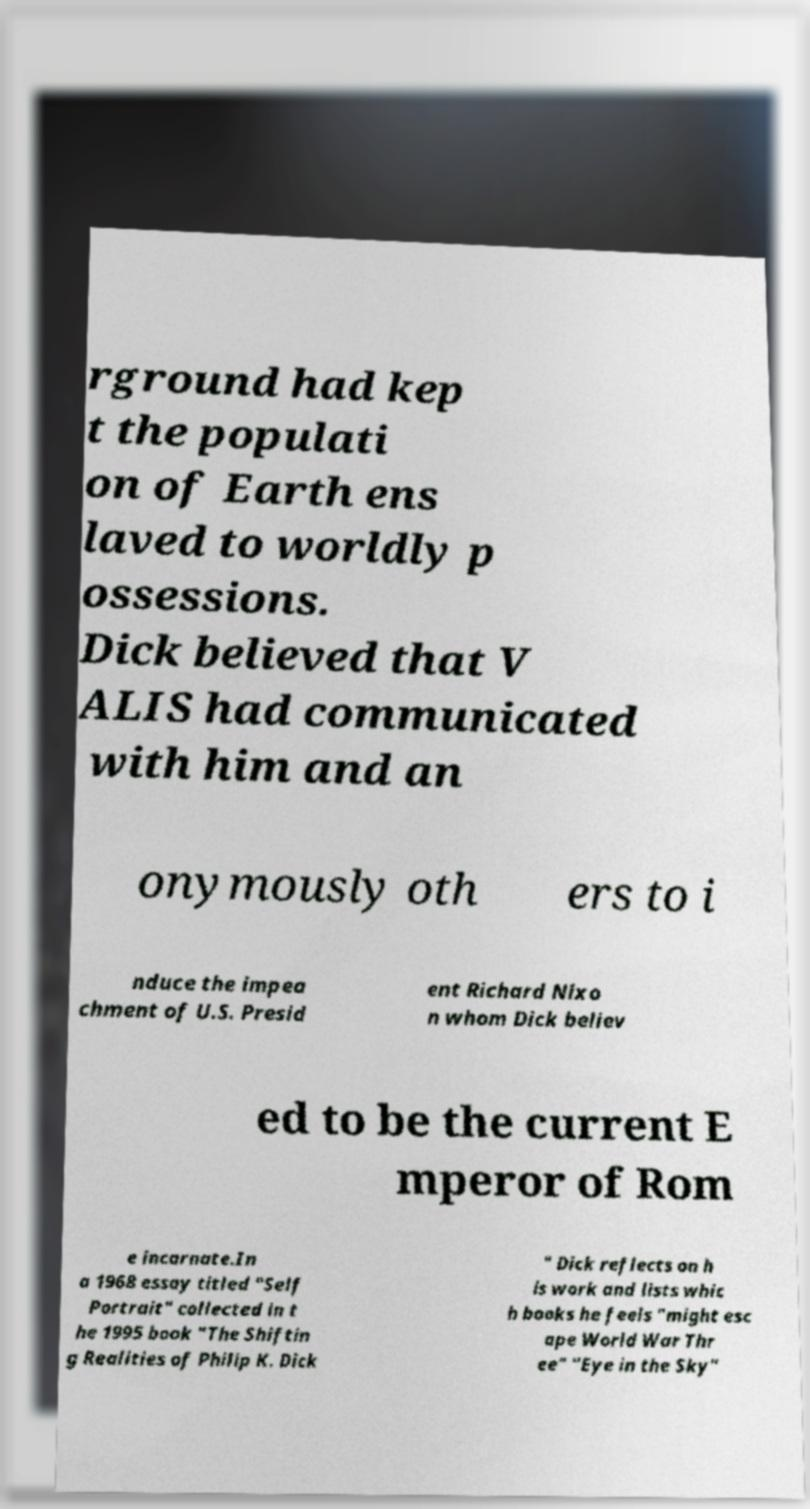Can you accurately transcribe the text from the provided image for me? rground had kep t the populati on of Earth ens laved to worldly p ossessions. Dick believed that V ALIS had communicated with him and an onymously oth ers to i nduce the impea chment of U.S. Presid ent Richard Nixo n whom Dick believ ed to be the current E mperor of Rom e incarnate.In a 1968 essay titled "Self Portrait" collected in t he 1995 book "The Shiftin g Realities of Philip K. Dick " Dick reflects on h is work and lists whic h books he feels "might esc ape World War Thr ee" "Eye in the Sky" 